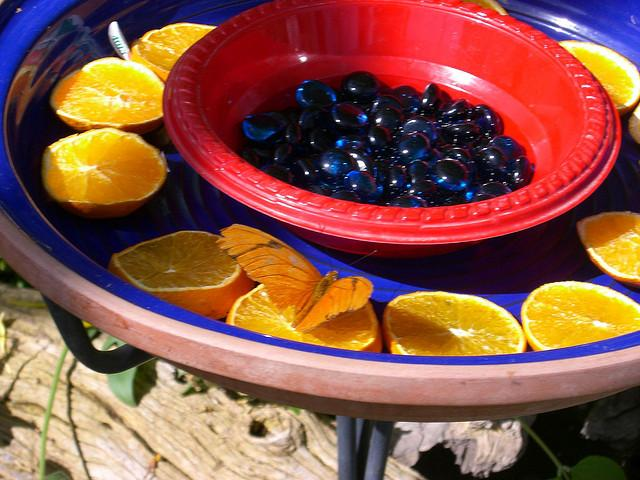What color are the beads inside of the red bowl? Please explain your reasoning. blue. The beads in the bowl are this color. 